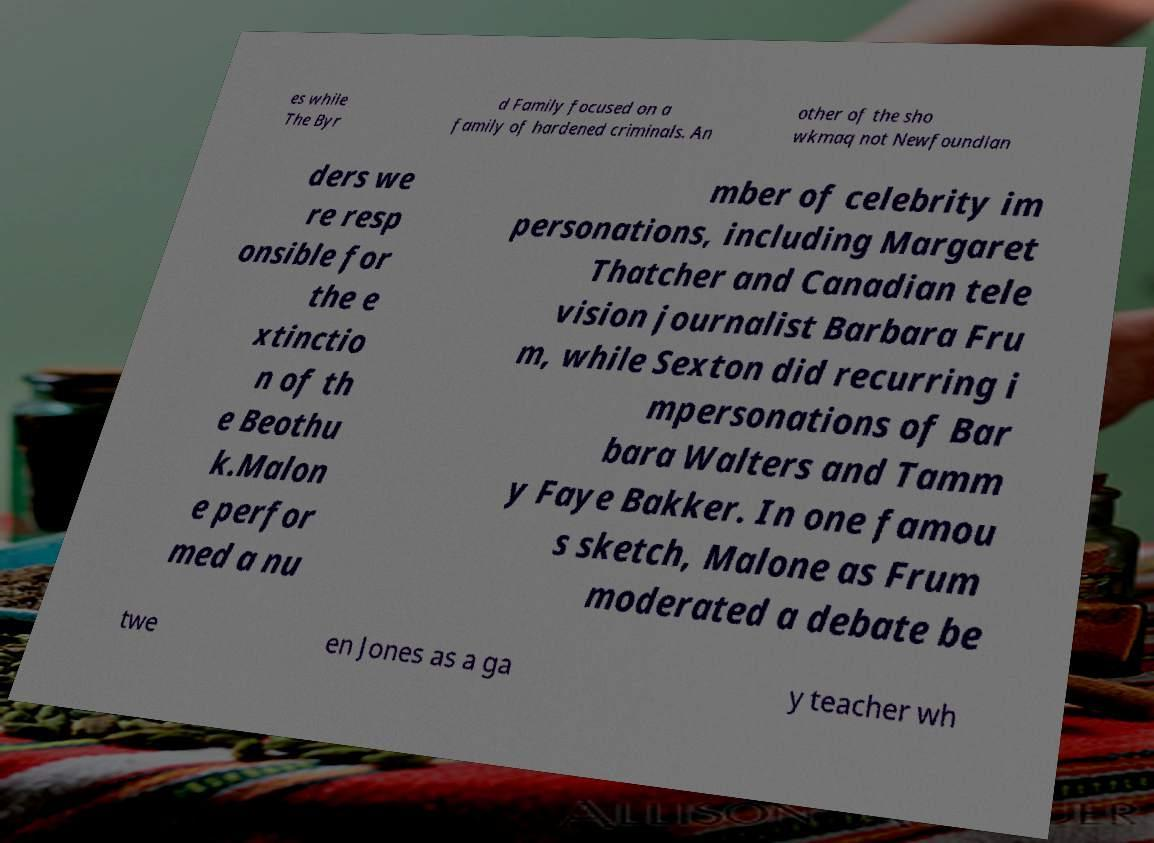Please identify and transcribe the text found in this image. es while The Byr d Family focused on a family of hardened criminals. An other of the sho wkmaq not Newfoundlan ders we re resp onsible for the e xtinctio n of th e Beothu k.Malon e perfor med a nu mber of celebrity im personations, including Margaret Thatcher and Canadian tele vision journalist Barbara Fru m, while Sexton did recurring i mpersonations of Bar bara Walters and Tamm y Faye Bakker. In one famou s sketch, Malone as Frum moderated a debate be twe en Jones as a ga y teacher wh 